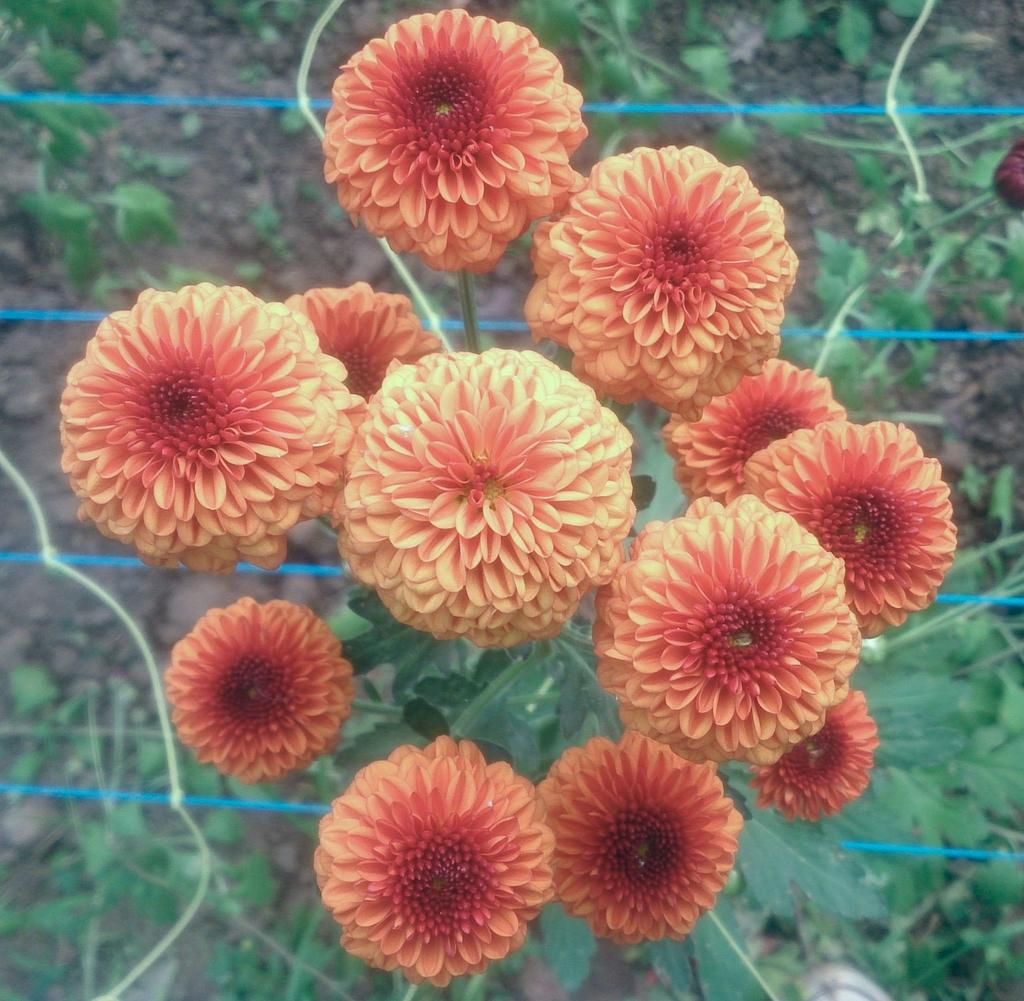What type of living organisms can be seen in the image? There are flowers and plants visible in the image. What objects can be seen in the background of the image? There are ropes and plants in the background of the image. What is visible on the ground in the image? The ground is visible in the background of the image. Who is the expert in the image providing advice on music? There is no expert or music present in the image; it features flowers, plants, and ropes. What type of umbrella is being used to protect the plants from the sun? There is no umbrella present in the image; it only shows flowers, plants, and ropes. 